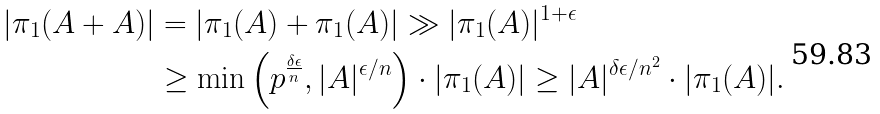Convert formula to latex. <formula><loc_0><loc_0><loc_500><loc_500>| \pi _ { 1 } ( A + A ) | & = | \pi _ { 1 } ( A ) + \pi _ { 1 } ( A ) | \gg | \pi _ { 1 } ( A ) | ^ { 1 + \epsilon } \\ & \geq \min \left ( p ^ { \frac { \delta \epsilon } { n } } , | A | ^ { \epsilon / n } \right ) \cdot | \pi _ { 1 } ( A ) | \geq | A | ^ { \delta \epsilon / n ^ { 2 } } \cdot | \pi _ { 1 } ( A ) | .</formula> 